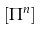<formula> <loc_0><loc_0><loc_500><loc_500>\left [ \Pi ^ { n } \right ]</formula> 